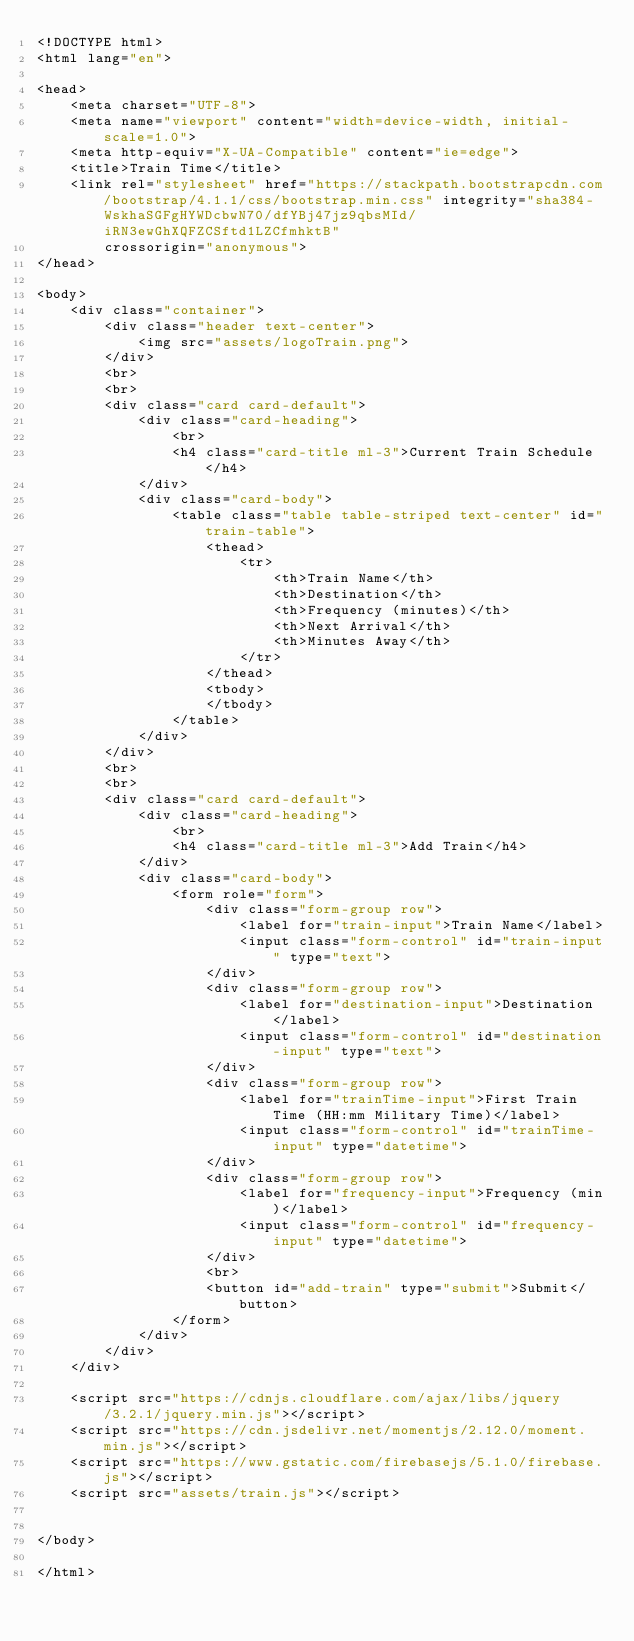<code> <loc_0><loc_0><loc_500><loc_500><_HTML_><!DOCTYPE html>
<html lang="en">

<head>
    <meta charset="UTF-8">
    <meta name="viewport" content="width=device-width, initial-scale=1.0">
    <meta http-equiv="X-UA-Compatible" content="ie=edge">
    <title>Train Time</title>
    <link rel="stylesheet" href="https://stackpath.bootstrapcdn.com/bootstrap/4.1.1/css/bootstrap.min.css" integrity="sha384-WskhaSGFgHYWDcbwN70/dfYBj47jz9qbsMId/iRN3ewGhXQFZCSftd1LZCfmhktB"
        crossorigin="anonymous">
</head>

<body>
    <div class="container">
        <div class="header text-center">
            <img src="assets/logoTrain.png">
        </div>
        <br>
        <br>
        <div class="card card-default">
            <div class="card-heading">
                <br>
                <h4 class="card-title ml-3">Current Train Schedule</h4>
            </div>
            <div class="card-body">
                <table class="table table-striped text-center" id="train-table">
                    <thead>
                        <tr>
                            <th>Train Name</th>
                            <th>Destination</th>
                            <th>Frequency (minutes)</th>
                            <th>Next Arrival</th>
                            <th>Minutes Away</th>
                        </tr>
                    </thead>
                    <tbody>
                    </tbody>
                </table>
            </div>
        </div>
        <br>
        <br>
        <div class="card card-default">
            <div class="card-heading">
                <br>
                <h4 class="card-title ml-3">Add Train</h4>
            </div>
            <div class="card-body">
                <form role="form">
                    <div class="form-group row">
                        <label for="train-input">Train Name</label>
                        <input class="form-control" id="train-input" type="text">
                    </div>
                    <div class="form-group row">
                        <label for="destination-input">Destination</label>
                        <input class="form-control" id="destination-input" type="text">
                    </div>
                    <div class="form-group row">
                        <label for="trainTime-input">First Train Time (HH:mm Military Time)</label>
                        <input class="form-control" id="trainTime-input" type="datetime">
                    </div>
                    <div class="form-group row">
                        <label for="frequency-input">Frequency (min)</label>
                        <input class="form-control" id="frequency-input" type="datetime">
                    </div>
                    <br>
                    <button id="add-train" type="submit">Submit</button>
                </form>
            </div>
        </div>
    </div>

    <script src="https://cdnjs.cloudflare.com/ajax/libs/jquery/3.2.1/jquery.min.js"></script>
    <script src="https://cdn.jsdelivr.net/momentjs/2.12.0/moment.min.js"></script>
    <script src="https://www.gstatic.com/firebasejs/5.1.0/firebase.js"></script>
    <script src="assets/train.js"></script>


</body>

</html></code> 